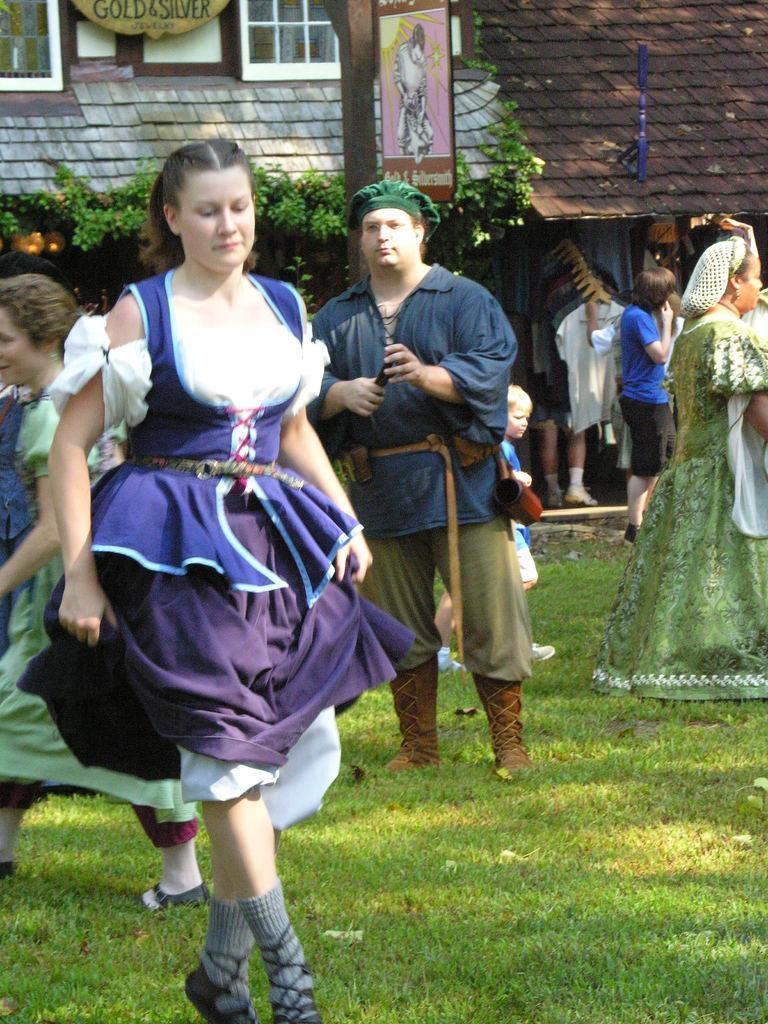Please provide a concise description of this image. In this image we can see a group of people are standing on the ground, here is the grass, here is the house, here is the window, here is the light. 